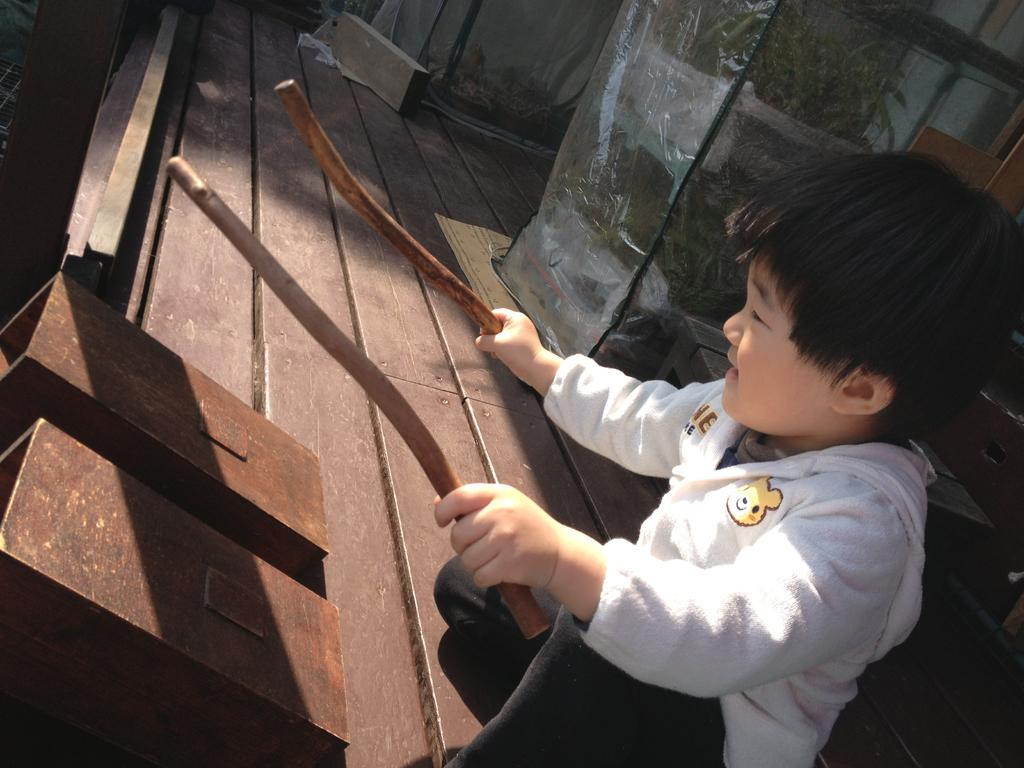Who is the main subject in the image? There is a boy in the image. What is the boy holding in his hand? The boy is holding sticks in his hand. What objects are in front of the boy? There are two boxes in front of the boy. What can be seen in the background of the image? There are two covers in the background of the image. How many legs does the part in the image have? There is no part mentioned in the image, and therefore no legs can be counted. 